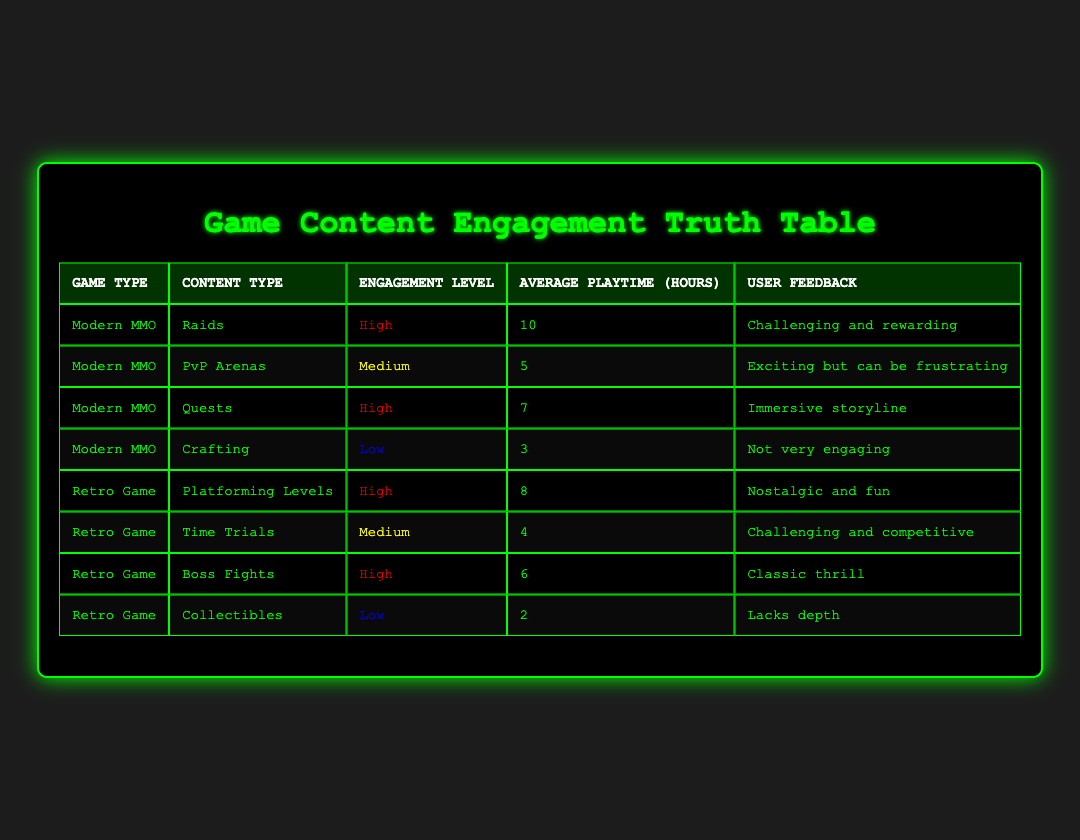What is the engagement level for Raids in Modern MMO? The engagement level for Raids is listed in the table under the Modern MMO category. It states "High" for this content type.
Answer: High What is the average playtime for Crafting in Modern MMO? The table shows that the average playtime for Crafting is 3 hours indicated in the respective row under Modern MMO.
Answer: 3 hours Are players more engaged with Boss Fights in Retro Games compared to PvP Arenas in Modern MMOs? The engagement level for Boss Fights is "High" while for PvP Arenas it is "Medium". Therefore, players are more engaged with Boss Fights than with PvP Arenas.
Answer: Yes What is the total average playtime for all High engagement levels? The average playtime for High engagement levels in the table are as follows: Raids (10), Quests (7), Platforming Levels (8), and Boss Fights (6). Summing these values gives 10 + 7 + 8 + 6 = 31, so the total average playtime is 31 hours for High engagement levels.
Answer: 31 hours Do Modern MMO games show a greater variety of content types compared to Retro Games? In the table, Modern MMO has four types of content (Raids, PvP Arenas, Quests, Crafting) while Retro Games also have four types (Platforming Levels, Time Trials, Boss Fights, Collectibles). The variety of content types is equal between Modern and Retro Games.
Answer: No What is the engagement level for collectibles in Retro Games? The engagement level for Collectibles is indicated in the Retro Game section of the table, which states "Low".
Answer: Low Calculate the average engagement level for Modern MMOs expressed numerically (High=3, Medium=2, Low=1). In Modern MMOs, there are 2 High (Raids and Quests), 1 Medium (PvP Arenas), and 1 Low (Crafting). Calculating: (2*3 + 1*2 + 1*1) / 4 = (6 + 2 + 1) / 4 = 9 / 4 = 2.25, indicating an overall average engagement level of 2.25.
Answer: 2.25 Is the average playtime for Time Trials in Retro Games greater than that for PvP Arenas in Modern MMOs? The average playtime for Time Trials is 4 hours and for PvP Arenas it is 5 hours. Since 4 is less than 5, Time Trials do not have a greater average playtime.
Answer: No 